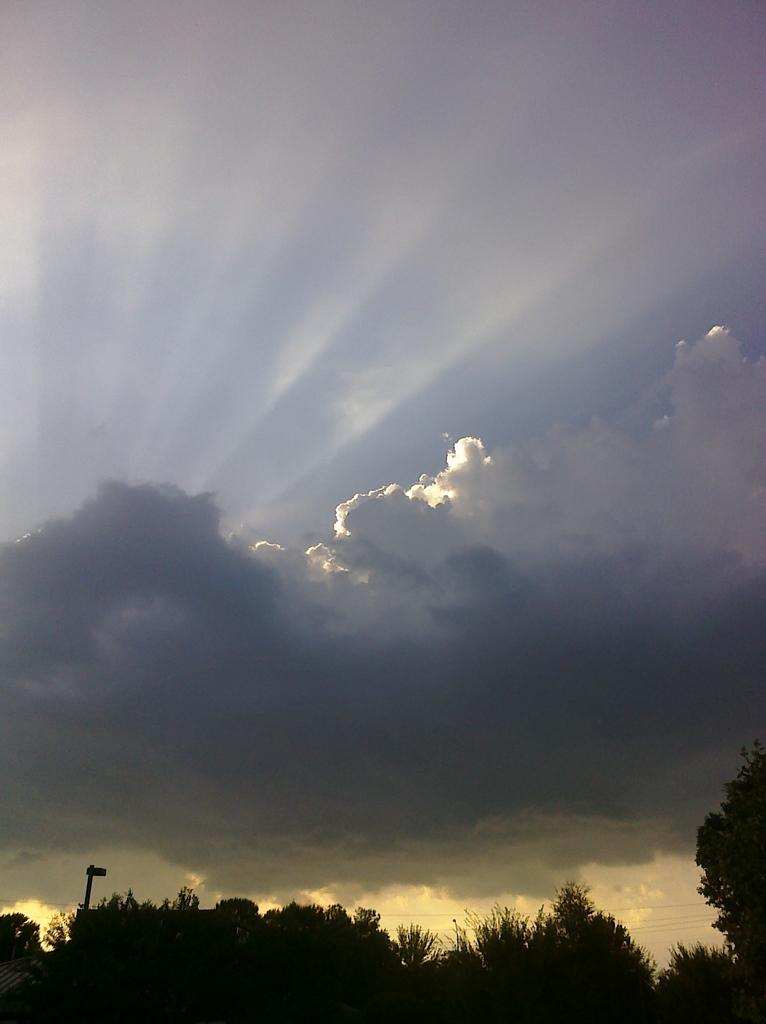What type of vegetation is at the bottom of the image? There are trees at the bottom of the image. What part of the natural environment is visible at the top of the image? The sky is visible at the top of the image. How would you describe the sky in the image? The sky is cloudy in the image. What type of jelly can be seen in the image? There is no jelly present in the image. What scent is associated with the image? The image does not convey any specific scent. 